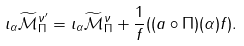Convert formula to latex. <formula><loc_0><loc_0><loc_500><loc_500>\iota _ { \alpha } \widetilde { \mathcal { M } } _ { \Pi } ^ { \nu ^ { \prime } } = \iota _ { \alpha } \widetilde { \mathcal { M } } _ { \Pi } ^ { \nu } + { \frac { 1 } { f } } ( ( a \circ \Pi ) ( \alpha ) f ) .</formula> 